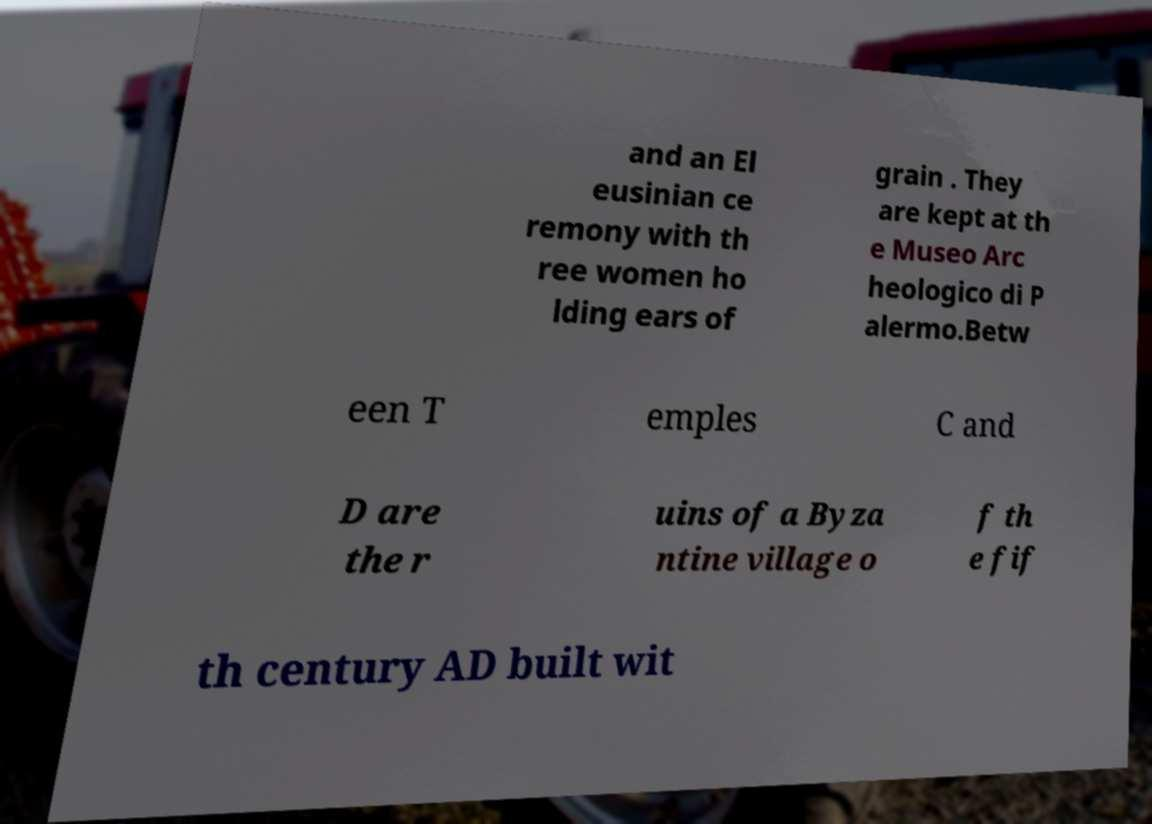Can you read and provide the text displayed in the image?This photo seems to have some interesting text. Can you extract and type it out for me? and an El eusinian ce remony with th ree women ho lding ears of grain . They are kept at th e Museo Arc heologico di P alermo.Betw een T emples C and D are the r uins of a Byza ntine village o f th e fif th century AD built wit 